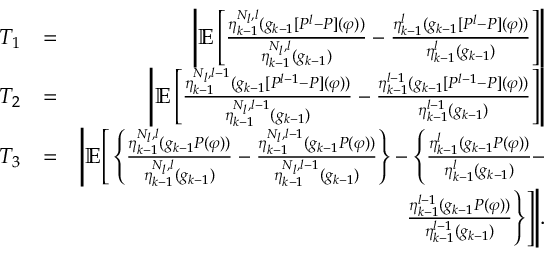<formula> <loc_0><loc_0><loc_500><loc_500>\begin{array} { r l r } { T _ { 1 } } & { = } & { \left | \mathbb { E } \left [ \frac { \eta _ { k - 1 } ^ { N _ { l } , l } ( g _ { k - 1 } [ P ^ { l } - P ] ( \varphi ) ) } { \eta _ { k - 1 } ^ { N _ { l } , l } ( g _ { k - 1 } ) } - \frac { \eta _ { k - 1 } ^ { l } ( g _ { k - 1 } [ P ^ { l } - P ] ( \varphi ) ) } { \eta _ { k - 1 } ^ { l } ( g _ { k - 1 } ) } \right ] \right | } \\ { T _ { 2 } } & { = } & { \left | \mathbb { E } \left [ \frac { \eta _ { k - 1 } ^ { N _ { l } , l - 1 } ( g _ { k - 1 } [ P ^ { l - 1 } - P ] ( \varphi ) ) } { \eta _ { k - 1 } ^ { N _ { l } , l - 1 } ( g _ { k - 1 } ) } - \frac { \eta _ { k - 1 } ^ { l - 1 } ( g _ { k - 1 } [ P ^ { l - 1 } - P ] ( \varphi ) ) } { \eta _ { k - 1 } ^ { l - 1 } ( g _ { k - 1 } ) } \right ] \right | } \\ { T _ { 3 } } & { = } & { \left | \mathbb { E } \left [ \left \{ \frac { \eta _ { k - 1 } ^ { N _ { l } , l } ( g _ { k - 1 } P ( \varphi ) ) } { \eta _ { k - 1 } ^ { N _ { l } , l } ( g _ { k - 1 } ) } - \frac { \eta _ { k - 1 } ^ { N _ { l } , l - 1 } ( g _ { k - 1 } P ( \varphi ) ) } { \eta _ { k - 1 } ^ { N _ { l } , l - 1 } ( g _ { k - 1 } ) } \right \} - \left \{ \frac { \eta _ { k - 1 } ^ { l } ( g _ { k - 1 } P ( \varphi ) ) } { \eta _ { k - 1 } ^ { l } ( g _ { k - 1 } ) } - } \\ & { \frac { \eta _ { k - 1 } ^ { l - 1 } ( g _ { k - 1 } P ( \varphi ) ) } { \eta _ { k - 1 } ^ { l - 1 } ( g _ { k - 1 } ) } \right \} \right ] \right | . } \end{array}</formula> 